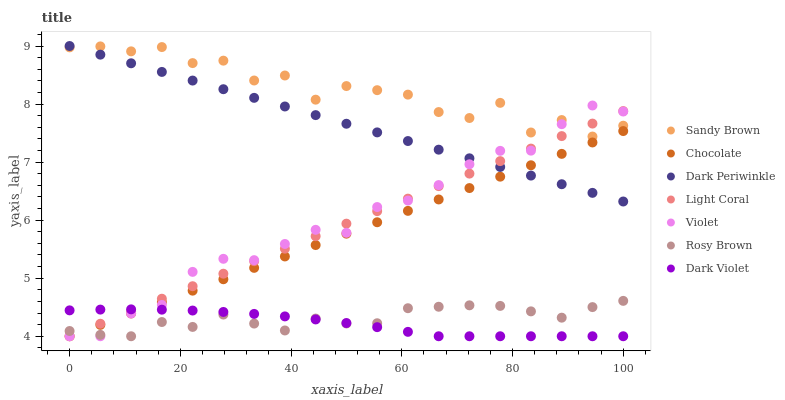Does Dark Violet have the minimum area under the curve?
Answer yes or no. Yes. Does Sandy Brown have the maximum area under the curve?
Answer yes or no. Yes. Does Chocolate have the minimum area under the curve?
Answer yes or no. No. Does Chocolate have the maximum area under the curve?
Answer yes or no. No. Is Light Coral the smoothest?
Answer yes or no. Yes. Is Sandy Brown the roughest?
Answer yes or no. Yes. Is Dark Violet the smoothest?
Answer yes or no. No. Is Dark Violet the roughest?
Answer yes or no. No. Does Rosy Brown have the lowest value?
Answer yes or no. Yes. Does Sandy Brown have the lowest value?
Answer yes or no. No. Does Dark Periwinkle have the highest value?
Answer yes or no. Yes. Does Chocolate have the highest value?
Answer yes or no. No. Is Chocolate less than Sandy Brown?
Answer yes or no. Yes. Is Dark Periwinkle greater than Dark Violet?
Answer yes or no. Yes. Does Light Coral intersect Violet?
Answer yes or no. Yes. Is Light Coral less than Violet?
Answer yes or no. No. Is Light Coral greater than Violet?
Answer yes or no. No. Does Chocolate intersect Sandy Brown?
Answer yes or no. No. 